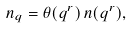Convert formula to latex. <formula><loc_0><loc_0><loc_500><loc_500>n _ { q } = \theta ( q ^ { r } ) \, n ( q ^ { r } ) ,</formula> 